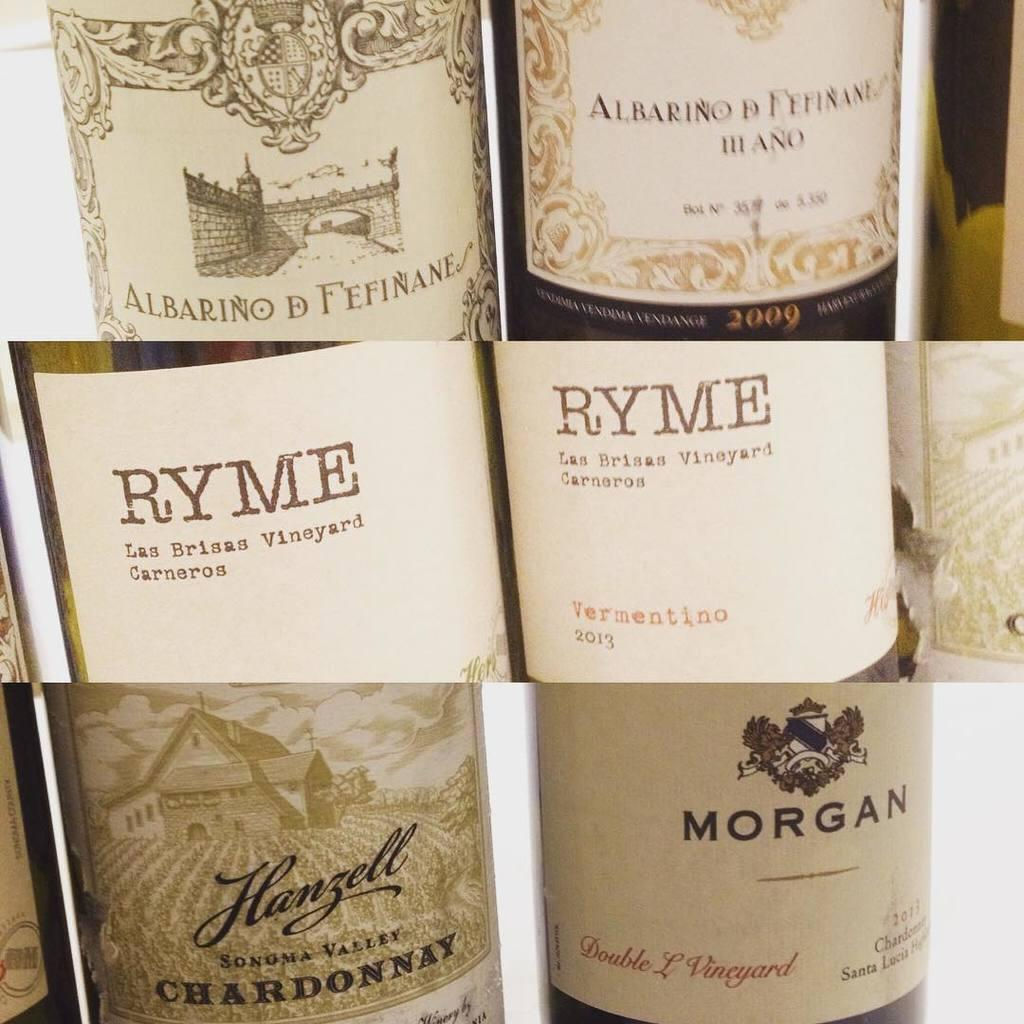<image>
Relay a brief, clear account of the picture shown. An assortment of wine including one from Ryme and another from Morgan. 